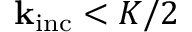<formula> <loc_0><loc_0><loc_500><loc_500>k _ { i n c } < K / 2</formula> 